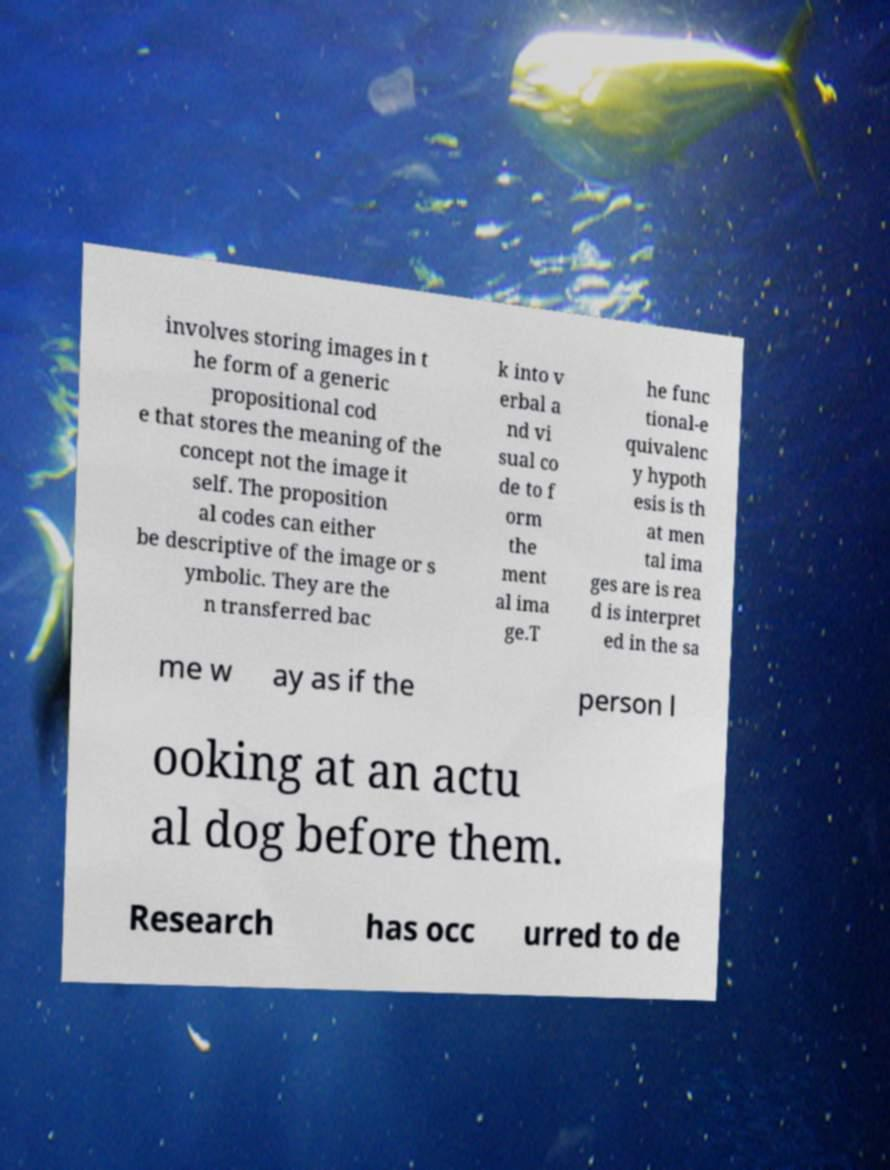I need the written content from this picture converted into text. Can you do that? involves storing images in t he form of a generic propositional cod e that stores the meaning of the concept not the image it self. The proposition al codes can either be descriptive of the image or s ymbolic. They are the n transferred bac k into v erbal a nd vi sual co de to f orm the ment al ima ge.T he func tional-e quivalenc y hypoth esis is th at men tal ima ges are is rea d is interpret ed in the sa me w ay as if the person l ooking at an actu al dog before them. Research has occ urred to de 